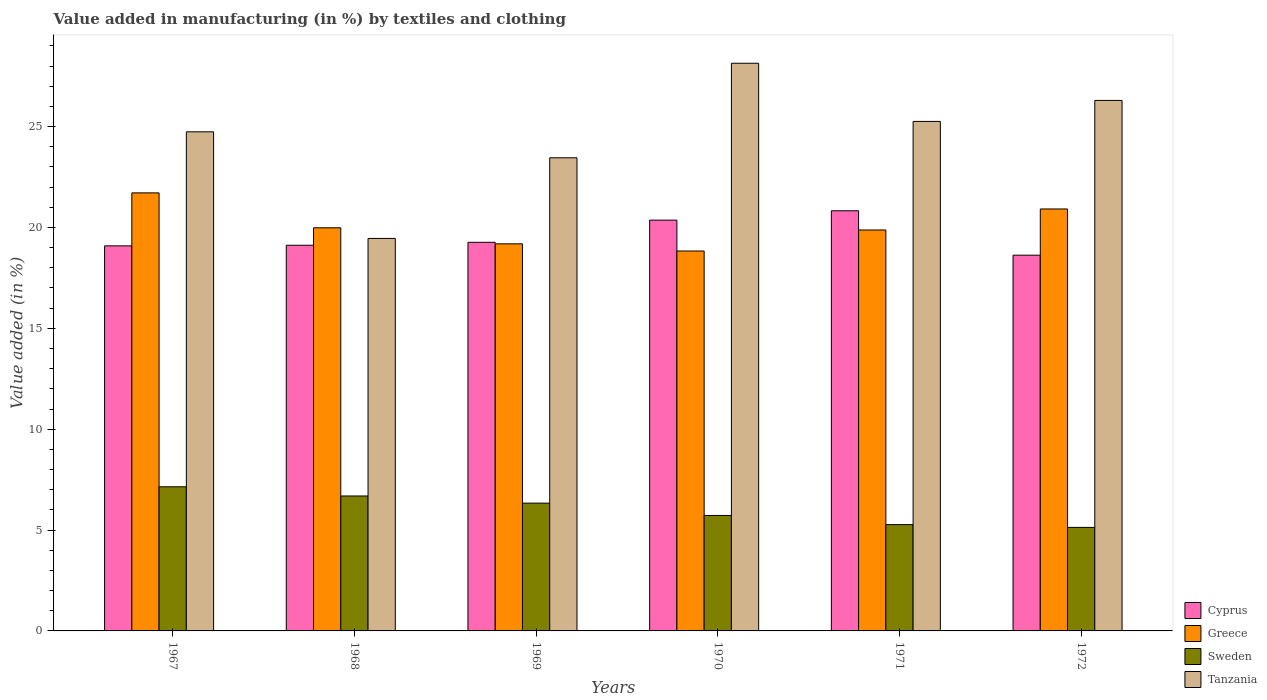How many groups of bars are there?
Provide a short and direct response. 6. Are the number of bars per tick equal to the number of legend labels?
Offer a terse response. Yes. What is the label of the 4th group of bars from the left?
Offer a very short reply. 1970. What is the percentage of value added in manufacturing by textiles and clothing in Greece in 1969?
Keep it short and to the point. 19.19. Across all years, what is the maximum percentage of value added in manufacturing by textiles and clothing in Sweden?
Give a very brief answer. 7.14. Across all years, what is the minimum percentage of value added in manufacturing by textiles and clothing in Greece?
Your response must be concise. 18.83. In which year was the percentage of value added in manufacturing by textiles and clothing in Cyprus maximum?
Ensure brevity in your answer.  1971. In which year was the percentage of value added in manufacturing by textiles and clothing in Cyprus minimum?
Provide a short and direct response. 1972. What is the total percentage of value added in manufacturing by textiles and clothing in Tanzania in the graph?
Your response must be concise. 147.35. What is the difference between the percentage of value added in manufacturing by textiles and clothing in Sweden in 1967 and that in 1971?
Give a very brief answer. 1.87. What is the difference between the percentage of value added in manufacturing by textiles and clothing in Tanzania in 1969 and the percentage of value added in manufacturing by textiles and clothing in Greece in 1970?
Make the answer very short. 4.62. What is the average percentage of value added in manufacturing by textiles and clothing in Cyprus per year?
Keep it short and to the point. 19.55. In the year 1972, what is the difference between the percentage of value added in manufacturing by textiles and clothing in Greece and percentage of value added in manufacturing by textiles and clothing in Cyprus?
Offer a terse response. 2.29. In how many years, is the percentage of value added in manufacturing by textiles and clothing in Cyprus greater than 4 %?
Make the answer very short. 6. What is the ratio of the percentage of value added in manufacturing by textiles and clothing in Tanzania in 1967 to that in 1969?
Provide a short and direct response. 1.05. What is the difference between the highest and the second highest percentage of value added in manufacturing by textiles and clothing in Greece?
Give a very brief answer. 0.8. What is the difference between the highest and the lowest percentage of value added in manufacturing by textiles and clothing in Greece?
Ensure brevity in your answer.  2.88. In how many years, is the percentage of value added in manufacturing by textiles and clothing in Greece greater than the average percentage of value added in manufacturing by textiles and clothing in Greece taken over all years?
Ensure brevity in your answer.  2. Is the sum of the percentage of value added in manufacturing by textiles and clothing in Tanzania in 1970 and 1972 greater than the maximum percentage of value added in manufacturing by textiles and clothing in Greece across all years?
Your answer should be compact. Yes. What does the 4th bar from the left in 1970 represents?
Provide a short and direct response. Tanzania. Is it the case that in every year, the sum of the percentage of value added in manufacturing by textiles and clothing in Cyprus and percentage of value added in manufacturing by textiles and clothing in Tanzania is greater than the percentage of value added in manufacturing by textiles and clothing in Greece?
Give a very brief answer. Yes. How many bars are there?
Your answer should be very brief. 24. Are all the bars in the graph horizontal?
Offer a terse response. No. How many years are there in the graph?
Provide a succinct answer. 6. How many legend labels are there?
Your answer should be very brief. 4. How are the legend labels stacked?
Your answer should be very brief. Vertical. What is the title of the graph?
Make the answer very short. Value added in manufacturing (in %) by textiles and clothing. What is the label or title of the X-axis?
Make the answer very short. Years. What is the label or title of the Y-axis?
Ensure brevity in your answer.  Value added (in %). What is the Value added (in %) of Cyprus in 1967?
Offer a terse response. 19.09. What is the Value added (in %) of Greece in 1967?
Give a very brief answer. 21.71. What is the Value added (in %) of Sweden in 1967?
Provide a short and direct response. 7.14. What is the Value added (in %) of Tanzania in 1967?
Give a very brief answer. 24.74. What is the Value added (in %) of Cyprus in 1968?
Keep it short and to the point. 19.12. What is the Value added (in %) in Greece in 1968?
Offer a very short reply. 19.98. What is the Value added (in %) in Sweden in 1968?
Offer a very short reply. 6.69. What is the Value added (in %) of Tanzania in 1968?
Provide a succinct answer. 19.46. What is the Value added (in %) of Cyprus in 1969?
Ensure brevity in your answer.  19.26. What is the Value added (in %) in Greece in 1969?
Make the answer very short. 19.19. What is the Value added (in %) of Sweden in 1969?
Provide a succinct answer. 6.33. What is the Value added (in %) in Tanzania in 1969?
Offer a very short reply. 23.45. What is the Value added (in %) of Cyprus in 1970?
Keep it short and to the point. 20.36. What is the Value added (in %) of Greece in 1970?
Provide a succinct answer. 18.83. What is the Value added (in %) in Sweden in 1970?
Provide a succinct answer. 5.72. What is the Value added (in %) of Tanzania in 1970?
Your response must be concise. 28.14. What is the Value added (in %) in Cyprus in 1971?
Your answer should be very brief. 20.83. What is the Value added (in %) of Greece in 1971?
Keep it short and to the point. 19.88. What is the Value added (in %) of Sweden in 1971?
Give a very brief answer. 5.27. What is the Value added (in %) in Tanzania in 1971?
Make the answer very short. 25.26. What is the Value added (in %) in Cyprus in 1972?
Offer a very short reply. 18.63. What is the Value added (in %) of Greece in 1972?
Offer a terse response. 20.92. What is the Value added (in %) of Sweden in 1972?
Give a very brief answer. 5.13. What is the Value added (in %) in Tanzania in 1972?
Keep it short and to the point. 26.3. Across all years, what is the maximum Value added (in %) of Cyprus?
Give a very brief answer. 20.83. Across all years, what is the maximum Value added (in %) of Greece?
Offer a terse response. 21.71. Across all years, what is the maximum Value added (in %) in Sweden?
Give a very brief answer. 7.14. Across all years, what is the maximum Value added (in %) of Tanzania?
Offer a terse response. 28.14. Across all years, what is the minimum Value added (in %) of Cyprus?
Your answer should be compact. 18.63. Across all years, what is the minimum Value added (in %) of Greece?
Keep it short and to the point. 18.83. Across all years, what is the minimum Value added (in %) in Sweden?
Make the answer very short. 5.13. Across all years, what is the minimum Value added (in %) in Tanzania?
Provide a succinct answer. 19.46. What is the total Value added (in %) in Cyprus in the graph?
Provide a succinct answer. 117.29. What is the total Value added (in %) in Greece in the graph?
Offer a terse response. 120.51. What is the total Value added (in %) of Sweden in the graph?
Offer a very short reply. 36.3. What is the total Value added (in %) of Tanzania in the graph?
Give a very brief answer. 147.35. What is the difference between the Value added (in %) of Cyprus in 1967 and that in 1968?
Give a very brief answer. -0.03. What is the difference between the Value added (in %) of Greece in 1967 and that in 1968?
Ensure brevity in your answer.  1.73. What is the difference between the Value added (in %) of Sweden in 1967 and that in 1968?
Your answer should be compact. 0.46. What is the difference between the Value added (in %) in Tanzania in 1967 and that in 1968?
Your response must be concise. 5.29. What is the difference between the Value added (in %) in Cyprus in 1967 and that in 1969?
Offer a terse response. -0.18. What is the difference between the Value added (in %) of Greece in 1967 and that in 1969?
Offer a terse response. 2.53. What is the difference between the Value added (in %) of Sweden in 1967 and that in 1969?
Offer a terse response. 0.81. What is the difference between the Value added (in %) of Tanzania in 1967 and that in 1969?
Give a very brief answer. 1.29. What is the difference between the Value added (in %) of Cyprus in 1967 and that in 1970?
Provide a succinct answer. -1.27. What is the difference between the Value added (in %) in Greece in 1967 and that in 1970?
Offer a terse response. 2.88. What is the difference between the Value added (in %) of Sweden in 1967 and that in 1970?
Ensure brevity in your answer.  1.42. What is the difference between the Value added (in %) of Tanzania in 1967 and that in 1970?
Make the answer very short. -3.4. What is the difference between the Value added (in %) of Cyprus in 1967 and that in 1971?
Keep it short and to the point. -1.74. What is the difference between the Value added (in %) of Greece in 1967 and that in 1971?
Make the answer very short. 1.84. What is the difference between the Value added (in %) of Sweden in 1967 and that in 1971?
Give a very brief answer. 1.87. What is the difference between the Value added (in %) in Tanzania in 1967 and that in 1971?
Ensure brevity in your answer.  -0.52. What is the difference between the Value added (in %) in Cyprus in 1967 and that in 1972?
Provide a short and direct response. 0.46. What is the difference between the Value added (in %) of Greece in 1967 and that in 1972?
Offer a very short reply. 0.8. What is the difference between the Value added (in %) in Sweden in 1967 and that in 1972?
Ensure brevity in your answer.  2.01. What is the difference between the Value added (in %) of Tanzania in 1967 and that in 1972?
Keep it short and to the point. -1.56. What is the difference between the Value added (in %) in Cyprus in 1968 and that in 1969?
Ensure brevity in your answer.  -0.15. What is the difference between the Value added (in %) in Greece in 1968 and that in 1969?
Give a very brief answer. 0.8. What is the difference between the Value added (in %) of Sweden in 1968 and that in 1969?
Make the answer very short. 0.35. What is the difference between the Value added (in %) in Tanzania in 1968 and that in 1969?
Make the answer very short. -4. What is the difference between the Value added (in %) of Cyprus in 1968 and that in 1970?
Offer a very short reply. -1.25. What is the difference between the Value added (in %) in Greece in 1968 and that in 1970?
Offer a very short reply. 1.15. What is the difference between the Value added (in %) in Sweden in 1968 and that in 1970?
Provide a short and direct response. 0.97. What is the difference between the Value added (in %) in Tanzania in 1968 and that in 1970?
Provide a succinct answer. -8.68. What is the difference between the Value added (in %) of Cyprus in 1968 and that in 1971?
Offer a terse response. -1.71. What is the difference between the Value added (in %) in Greece in 1968 and that in 1971?
Your answer should be very brief. 0.11. What is the difference between the Value added (in %) in Sweden in 1968 and that in 1971?
Your answer should be very brief. 1.42. What is the difference between the Value added (in %) in Tanzania in 1968 and that in 1971?
Make the answer very short. -5.8. What is the difference between the Value added (in %) in Cyprus in 1968 and that in 1972?
Your answer should be compact. 0.49. What is the difference between the Value added (in %) in Greece in 1968 and that in 1972?
Offer a very short reply. -0.93. What is the difference between the Value added (in %) of Sweden in 1968 and that in 1972?
Keep it short and to the point. 1.56. What is the difference between the Value added (in %) of Tanzania in 1968 and that in 1972?
Offer a very short reply. -6.84. What is the difference between the Value added (in %) in Cyprus in 1969 and that in 1970?
Ensure brevity in your answer.  -1.1. What is the difference between the Value added (in %) of Greece in 1969 and that in 1970?
Your answer should be very brief. 0.36. What is the difference between the Value added (in %) of Sweden in 1969 and that in 1970?
Offer a terse response. 0.61. What is the difference between the Value added (in %) of Tanzania in 1969 and that in 1970?
Your answer should be compact. -4.69. What is the difference between the Value added (in %) of Cyprus in 1969 and that in 1971?
Keep it short and to the point. -1.56. What is the difference between the Value added (in %) of Greece in 1969 and that in 1971?
Keep it short and to the point. -0.69. What is the difference between the Value added (in %) of Sweden in 1969 and that in 1971?
Offer a terse response. 1.06. What is the difference between the Value added (in %) in Tanzania in 1969 and that in 1971?
Ensure brevity in your answer.  -1.8. What is the difference between the Value added (in %) of Cyprus in 1969 and that in 1972?
Provide a succinct answer. 0.64. What is the difference between the Value added (in %) in Greece in 1969 and that in 1972?
Keep it short and to the point. -1.73. What is the difference between the Value added (in %) in Sweden in 1969 and that in 1972?
Provide a succinct answer. 1.2. What is the difference between the Value added (in %) in Tanzania in 1969 and that in 1972?
Offer a terse response. -2.84. What is the difference between the Value added (in %) in Cyprus in 1970 and that in 1971?
Provide a short and direct response. -0.46. What is the difference between the Value added (in %) in Greece in 1970 and that in 1971?
Your answer should be compact. -1.04. What is the difference between the Value added (in %) in Sweden in 1970 and that in 1971?
Provide a short and direct response. 0.45. What is the difference between the Value added (in %) of Tanzania in 1970 and that in 1971?
Give a very brief answer. 2.88. What is the difference between the Value added (in %) of Cyprus in 1970 and that in 1972?
Your answer should be compact. 1.74. What is the difference between the Value added (in %) of Greece in 1970 and that in 1972?
Offer a terse response. -2.08. What is the difference between the Value added (in %) in Sweden in 1970 and that in 1972?
Your answer should be compact. 0.59. What is the difference between the Value added (in %) in Tanzania in 1970 and that in 1972?
Offer a terse response. 1.84. What is the difference between the Value added (in %) in Cyprus in 1971 and that in 1972?
Provide a succinct answer. 2.2. What is the difference between the Value added (in %) of Greece in 1971 and that in 1972?
Keep it short and to the point. -1.04. What is the difference between the Value added (in %) of Sweden in 1971 and that in 1972?
Make the answer very short. 0.14. What is the difference between the Value added (in %) of Tanzania in 1971 and that in 1972?
Give a very brief answer. -1.04. What is the difference between the Value added (in %) in Cyprus in 1967 and the Value added (in %) in Greece in 1968?
Keep it short and to the point. -0.9. What is the difference between the Value added (in %) of Cyprus in 1967 and the Value added (in %) of Tanzania in 1968?
Make the answer very short. -0.37. What is the difference between the Value added (in %) of Greece in 1967 and the Value added (in %) of Sweden in 1968?
Ensure brevity in your answer.  15.03. What is the difference between the Value added (in %) in Greece in 1967 and the Value added (in %) in Tanzania in 1968?
Your answer should be compact. 2.26. What is the difference between the Value added (in %) of Sweden in 1967 and the Value added (in %) of Tanzania in 1968?
Your response must be concise. -12.31. What is the difference between the Value added (in %) in Cyprus in 1967 and the Value added (in %) in Greece in 1969?
Offer a very short reply. -0.1. What is the difference between the Value added (in %) in Cyprus in 1967 and the Value added (in %) in Sweden in 1969?
Your response must be concise. 12.75. What is the difference between the Value added (in %) in Cyprus in 1967 and the Value added (in %) in Tanzania in 1969?
Provide a succinct answer. -4.37. What is the difference between the Value added (in %) of Greece in 1967 and the Value added (in %) of Sweden in 1969?
Offer a terse response. 15.38. What is the difference between the Value added (in %) in Greece in 1967 and the Value added (in %) in Tanzania in 1969?
Keep it short and to the point. -1.74. What is the difference between the Value added (in %) of Sweden in 1967 and the Value added (in %) of Tanzania in 1969?
Provide a succinct answer. -16.31. What is the difference between the Value added (in %) of Cyprus in 1967 and the Value added (in %) of Greece in 1970?
Provide a succinct answer. 0.26. What is the difference between the Value added (in %) in Cyprus in 1967 and the Value added (in %) in Sweden in 1970?
Provide a succinct answer. 13.37. What is the difference between the Value added (in %) of Cyprus in 1967 and the Value added (in %) of Tanzania in 1970?
Keep it short and to the point. -9.05. What is the difference between the Value added (in %) in Greece in 1967 and the Value added (in %) in Sweden in 1970?
Make the answer very short. 15.99. What is the difference between the Value added (in %) of Greece in 1967 and the Value added (in %) of Tanzania in 1970?
Keep it short and to the point. -6.43. What is the difference between the Value added (in %) in Sweden in 1967 and the Value added (in %) in Tanzania in 1970?
Your answer should be compact. -21. What is the difference between the Value added (in %) of Cyprus in 1967 and the Value added (in %) of Greece in 1971?
Ensure brevity in your answer.  -0.79. What is the difference between the Value added (in %) of Cyprus in 1967 and the Value added (in %) of Sweden in 1971?
Offer a terse response. 13.82. What is the difference between the Value added (in %) in Cyprus in 1967 and the Value added (in %) in Tanzania in 1971?
Ensure brevity in your answer.  -6.17. What is the difference between the Value added (in %) of Greece in 1967 and the Value added (in %) of Sweden in 1971?
Your answer should be very brief. 16.44. What is the difference between the Value added (in %) of Greece in 1967 and the Value added (in %) of Tanzania in 1971?
Your answer should be very brief. -3.54. What is the difference between the Value added (in %) in Sweden in 1967 and the Value added (in %) in Tanzania in 1971?
Your answer should be very brief. -18.11. What is the difference between the Value added (in %) of Cyprus in 1967 and the Value added (in %) of Greece in 1972?
Keep it short and to the point. -1.83. What is the difference between the Value added (in %) of Cyprus in 1967 and the Value added (in %) of Sweden in 1972?
Your answer should be compact. 13.96. What is the difference between the Value added (in %) of Cyprus in 1967 and the Value added (in %) of Tanzania in 1972?
Your response must be concise. -7.21. What is the difference between the Value added (in %) in Greece in 1967 and the Value added (in %) in Sweden in 1972?
Provide a succinct answer. 16.58. What is the difference between the Value added (in %) of Greece in 1967 and the Value added (in %) of Tanzania in 1972?
Your response must be concise. -4.58. What is the difference between the Value added (in %) in Sweden in 1967 and the Value added (in %) in Tanzania in 1972?
Keep it short and to the point. -19.15. What is the difference between the Value added (in %) in Cyprus in 1968 and the Value added (in %) in Greece in 1969?
Provide a succinct answer. -0.07. What is the difference between the Value added (in %) in Cyprus in 1968 and the Value added (in %) in Sweden in 1969?
Give a very brief answer. 12.78. What is the difference between the Value added (in %) in Cyprus in 1968 and the Value added (in %) in Tanzania in 1969?
Keep it short and to the point. -4.33. What is the difference between the Value added (in %) of Greece in 1968 and the Value added (in %) of Sweden in 1969?
Give a very brief answer. 13.65. What is the difference between the Value added (in %) in Greece in 1968 and the Value added (in %) in Tanzania in 1969?
Provide a succinct answer. -3.47. What is the difference between the Value added (in %) in Sweden in 1968 and the Value added (in %) in Tanzania in 1969?
Keep it short and to the point. -16.77. What is the difference between the Value added (in %) of Cyprus in 1968 and the Value added (in %) of Greece in 1970?
Provide a succinct answer. 0.29. What is the difference between the Value added (in %) in Cyprus in 1968 and the Value added (in %) in Sweden in 1970?
Make the answer very short. 13.4. What is the difference between the Value added (in %) in Cyprus in 1968 and the Value added (in %) in Tanzania in 1970?
Your answer should be very brief. -9.02. What is the difference between the Value added (in %) of Greece in 1968 and the Value added (in %) of Sweden in 1970?
Your answer should be very brief. 14.26. What is the difference between the Value added (in %) in Greece in 1968 and the Value added (in %) in Tanzania in 1970?
Provide a succinct answer. -8.16. What is the difference between the Value added (in %) in Sweden in 1968 and the Value added (in %) in Tanzania in 1970?
Offer a terse response. -21.45. What is the difference between the Value added (in %) of Cyprus in 1968 and the Value added (in %) of Greece in 1971?
Ensure brevity in your answer.  -0.76. What is the difference between the Value added (in %) in Cyprus in 1968 and the Value added (in %) in Sweden in 1971?
Offer a very short reply. 13.85. What is the difference between the Value added (in %) of Cyprus in 1968 and the Value added (in %) of Tanzania in 1971?
Ensure brevity in your answer.  -6.14. What is the difference between the Value added (in %) in Greece in 1968 and the Value added (in %) in Sweden in 1971?
Offer a very short reply. 14.71. What is the difference between the Value added (in %) in Greece in 1968 and the Value added (in %) in Tanzania in 1971?
Offer a terse response. -5.27. What is the difference between the Value added (in %) of Sweden in 1968 and the Value added (in %) of Tanzania in 1971?
Give a very brief answer. -18.57. What is the difference between the Value added (in %) of Cyprus in 1968 and the Value added (in %) of Greece in 1972?
Keep it short and to the point. -1.8. What is the difference between the Value added (in %) in Cyprus in 1968 and the Value added (in %) in Sweden in 1972?
Your answer should be compact. 13.99. What is the difference between the Value added (in %) of Cyprus in 1968 and the Value added (in %) of Tanzania in 1972?
Your answer should be compact. -7.18. What is the difference between the Value added (in %) in Greece in 1968 and the Value added (in %) in Sweden in 1972?
Keep it short and to the point. 14.85. What is the difference between the Value added (in %) of Greece in 1968 and the Value added (in %) of Tanzania in 1972?
Offer a terse response. -6.31. What is the difference between the Value added (in %) of Sweden in 1968 and the Value added (in %) of Tanzania in 1972?
Your response must be concise. -19.61. What is the difference between the Value added (in %) in Cyprus in 1969 and the Value added (in %) in Greece in 1970?
Your response must be concise. 0.43. What is the difference between the Value added (in %) of Cyprus in 1969 and the Value added (in %) of Sweden in 1970?
Your response must be concise. 13.54. What is the difference between the Value added (in %) of Cyprus in 1969 and the Value added (in %) of Tanzania in 1970?
Offer a terse response. -8.88. What is the difference between the Value added (in %) in Greece in 1969 and the Value added (in %) in Sweden in 1970?
Keep it short and to the point. 13.47. What is the difference between the Value added (in %) in Greece in 1969 and the Value added (in %) in Tanzania in 1970?
Your answer should be compact. -8.95. What is the difference between the Value added (in %) of Sweden in 1969 and the Value added (in %) of Tanzania in 1970?
Offer a very short reply. -21.81. What is the difference between the Value added (in %) of Cyprus in 1969 and the Value added (in %) of Greece in 1971?
Ensure brevity in your answer.  -0.61. What is the difference between the Value added (in %) in Cyprus in 1969 and the Value added (in %) in Sweden in 1971?
Offer a terse response. 13.99. What is the difference between the Value added (in %) of Cyprus in 1969 and the Value added (in %) of Tanzania in 1971?
Keep it short and to the point. -5.99. What is the difference between the Value added (in %) in Greece in 1969 and the Value added (in %) in Sweden in 1971?
Provide a short and direct response. 13.92. What is the difference between the Value added (in %) of Greece in 1969 and the Value added (in %) of Tanzania in 1971?
Your response must be concise. -6.07. What is the difference between the Value added (in %) of Sweden in 1969 and the Value added (in %) of Tanzania in 1971?
Keep it short and to the point. -18.92. What is the difference between the Value added (in %) of Cyprus in 1969 and the Value added (in %) of Greece in 1972?
Keep it short and to the point. -1.65. What is the difference between the Value added (in %) of Cyprus in 1969 and the Value added (in %) of Sweden in 1972?
Give a very brief answer. 14.13. What is the difference between the Value added (in %) of Cyprus in 1969 and the Value added (in %) of Tanzania in 1972?
Give a very brief answer. -7.03. What is the difference between the Value added (in %) of Greece in 1969 and the Value added (in %) of Sweden in 1972?
Keep it short and to the point. 14.06. What is the difference between the Value added (in %) in Greece in 1969 and the Value added (in %) in Tanzania in 1972?
Offer a very short reply. -7.11. What is the difference between the Value added (in %) of Sweden in 1969 and the Value added (in %) of Tanzania in 1972?
Give a very brief answer. -19.96. What is the difference between the Value added (in %) in Cyprus in 1970 and the Value added (in %) in Greece in 1971?
Ensure brevity in your answer.  0.49. What is the difference between the Value added (in %) of Cyprus in 1970 and the Value added (in %) of Sweden in 1971?
Offer a very short reply. 15.09. What is the difference between the Value added (in %) of Cyprus in 1970 and the Value added (in %) of Tanzania in 1971?
Ensure brevity in your answer.  -4.89. What is the difference between the Value added (in %) in Greece in 1970 and the Value added (in %) in Sweden in 1971?
Keep it short and to the point. 13.56. What is the difference between the Value added (in %) of Greece in 1970 and the Value added (in %) of Tanzania in 1971?
Offer a terse response. -6.42. What is the difference between the Value added (in %) of Sweden in 1970 and the Value added (in %) of Tanzania in 1971?
Provide a short and direct response. -19.53. What is the difference between the Value added (in %) of Cyprus in 1970 and the Value added (in %) of Greece in 1972?
Your answer should be compact. -0.55. What is the difference between the Value added (in %) of Cyprus in 1970 and the Value added (in %) of Sweden in 1972?
Give a very brief answer. 15.23. What is the difference between the Value added (in %) of Cyprus in 1970 and the Value added (in %) of Tanzania in 1972?
Your response must be concise. -5.93. What is the difference between the Value added (in %) in Greece in 1970 and the Value added (in %) in Sweden in 1972?
Offer a very short reply. 13.7. What is the difference between the Value added (in %) in Greece in 1970 and the Value added (in %) in Tanzania in 1972?
Offer a very short reply. -7.47. What is the difference between the Value added (in %) of Sweden in 1970 and the Value added (in %) of Tanzania in 1972?
Keep it short and to the point. -20.57. What is the difference between the Value added (in %) of Cyprus in 1971 and the Value added (in %) of Greece in 1972?
Your response must be concise. -0.09. What is the difference between the Value added (in %) in Cyprus in 1971 and the Value added (in %) in Sweden in 1972?
Make the answer very short. 15.7. What is the difference between the Value added (in %) of Cyprus in 1971 and the Value added (in %) of Tanzania in 1972?
Offer a very short reply. -5.47. What is the difference between the Value added (in %) of Greece in 1971 and the Value added (in %) of Sweden in 1972?
Ensure brevity in your answer.  14.74. What is the difference between the Value added (in %) in Greece in 1971 and the Value added (in %) in Tanzania in 1972?
Provide a short and direct response. -6.42. What is the difference between the Value added (in %) of Sweden in 1971 and the Value added (in %) of Tanzania in 1972?
Your answer should be compact. -21.03. What is the average Value added (in %) of Cyprus per year?
Ensure brevity in your answer.  19.55. What is the average Value added (in %) in Greece per year?
Offer a very short reply. 20.09. What is the average Value added (in %) of Sweden per year?
Ensure brevity in your answer.  6.05. What is the average Value added (in %) in Tanzania per year?
Provide a short and direct response. 24.56. In the year 1967, what is the difference between the Value added (in %) of Cyprus and Value added (in %) of Greece?
Provide a short and direct response. -2.63. In the year 1967, what is the difference between the Value added (in %) of Cyprus and Value added (in %) of Sweden?
Your answer should be very brief. 11.94. In the year 1967, what is the difference between the Value added (in %) in Cyprus and Value added (in %) in Tanzania?
Give a very brief answer. -5.65. In the year 1967, what is the difference between the Value added (in %) in Greece and Value added (in %) in Sweden?
Offer a very short reply. 14.57. In the year 1967, what is the difference between the Value added (in %) of Greece and Value added (in %) of Tanzania?
Offer a terse response. -3.03. In the year 1967, what is the difference between the Value added (in %) in Sweden and Value added (in %) in Tanzania?
Make the answer very short. -17.6. In the year 1968, what is the difference between the Value added (in %) in Cyprus and Value added (in %) in Greece?
Provide a short and direct response. -0.87. In the year 1968, what is the difference between the Value added (in %) of Cyprus and Value added (in %) of Sweden?
Your answer should be very brief. 12.43. In the year 1968, what is the difference between the Value added (in %) in Cyprus and Value added (in %) in Tanzania?
Give a very brief answer. -0.34. In the year 1968, what is the difference between the Value added (in %) of Greece and Value added (in %) of Sweden?
Your response must be concise. 13.3. In the year 1968, what is the difference between the Value added (in %) of Greece and Value added (in %) of Tanzania?
Provide a succinct answer. 0.53. In the year 1968, what is the difference between the Value added (in %) in Sweden and Value added (in %) in Tanzania?
Your answer should be very brief. -12.77. In the year 1969, what is the difference between the Value added (in %) in Cyprus and Value added (in %) in Greece?
Keep it short and to the point. 0.08. In the year 1969, what is the difference between the Value added (in %) in Cyprus and Value added (in %) in Sweden?
Keep it short and to the point. 12.93. In the year 1969, what is the difference between the Value added (in %) in Cyprus and Value added (in %) in Tanzania?
Offer a terse response. -4.19. In the year 1969, what is the difference between the Value added (in %) in Greece and Value added (in %) in Sweden?
Provide a succinct answer. 12.85. In the year 1969, what is the difference between the Value added (in %) of Greece and Value added (in %) of Tanzania?
Give a very brief answer. -4.27. In the year 1969, what is the difference between the Value added (in %) of Sweden and Value added (in %) of Tanzania?
Offer a terse response. -17.12. In the year 1970, what is the difference between the Value added (in %) of Cyprus and Value added (in %) of Greece?
Your response must be concise. 1.53. In the year 1970, what is the difference between the Value added (in %) in Cyprus and Value added (in %) in Sweden?
Your answer should be compact. 14.64. In the year 1970, what is the difference between the Value added (in %) in Cyprus and Value added (in %) in Tanzania?
Provide a short and direct response. -7.78. In the year 1970, what is the difference between the Value added (in %) in Greece and Value added (in %) in Sweden?
Provide a short and direct response. 13.11. In the year 1970, what is the difference between the Value added (in %) of Greece and Value added (in %) of Tanzania?
Offer a very short reply. -9.31. In the year 1970, what is the difference between the Value added (in %) in Sweden and Value added (in %) in Tanzania?
Provide a succinct answer. -22.42. In the year 1971, what is the difference between the Value added (in %) of Cyprus and Value added (in %) of Greece?
Your answer should be very brief. 0.95. In the year 1971, what is the difference between the Value added (in %) of Cyprus and Value added (in %) of Sweden?
Make the answer very short. 15.56. In the year 1971, what is the difference between the Value added (in %) in Cyprus and Value added (in %) in Tanzania?
Provide a short and direct response. -4.43. In the year 1971, what is the difference between the Value added (in %) of Greece and Value added (in %) of Sweden?
Keep it short and to the point. 14.61. In the year 1971, what is the difference between the Value added (in %) of Greece and Value added (in %) of Tanzania?
Your response must be concise. -5.38. In the year 1971, what is the difference between the Value added (in %) in Sweden and Value added (in %) in Tanzania?
Give a very brief answer. -19.99. In the year 1972, what is the difference between the Value added (in %) in Cyprus and Value added (in %) in Greece?
Your answer should be compact. -2.29. In the year 1972, what is the difference between the Value added (in %) of Cyprus and Value added (in %) of Sweden?
Give a very brief answer. 13.49. In the year 1972, what is the difference between the Value added (in %) of Cyprus and Value added (in %) of Tanzania?
Keep it short and to the point. -7.67. In the year 1972, what is the difference between the Value added (in %) of Greece and Value added (in %) of Sweden?
Your response must be concise. 15.79. In the year 1972, what is the difference between the Value added (in %) in Greece and Value added (in %) in Tanzania?
Give a very brief answer. -5.38. In the year 1972, what is the difference between the Value added (in %) of Sweden and Value added (in %) of Tanzania?
Provide a short and direct response. -21.17. What is the ratio of the Value added (in %) of Greece in 1967 to that in 1968?
Your response must be concise. 1.09. What is the ratio of the Value added (in %) in Sweden in 1967 to that in 1968?
Provide a succinct answer. 1.07. What is the ratio of the Value added (in %) of Tanzania in 1967 to that in 1968?
Offer a terse response. 1.27. What is the ratio of the Value added (in %) in Cyprus in 1967 to that in 1969?
Give a very brief answer. 0.99. What is the ratio of the Value added (in %) of Greece in 1967 to that in 1969?
Keep it short and to the point. 1.13. What is the ratio of the Value added (in %) in Sweden in 1967 to that in 1969?
Give a very brief answer. 1.13. What is the ratio of the Value added (in %) in Tanzania in 1967 to that in 1969?
Give a very brief answer. 1.05. What is the ratio of the Value added (in %) in Cyprus in 1967 to that in 1970?
Make the answer very short. 0.94. What is the ratio of the Value added (in %) of Greece in 1967 to that in 1970?
Make the answer very short. 1.15. What is the ratio of the Value added (in %) in Sweden in 1967 to that in 1970?
Offer a very short reply. 1.25. What is the ratio of the Value added (in %) of Tanzania in 1967 to that in 1970?
Offer a terse response. 0.88. What is the ratio of the Value added (in %) of Cyprus in 1967 to that in 1971?
Your response must be concise. 0.92. What is the ratio of the Value added (in %) in Greece in 1967 to that in 1971?
Ensure brevity in your answer.  1.09. What is the ratio of the Value added (in %) of Sweden in 1967 to that in 1971?
Provide a succinct answer. 1.36. What is the ratio of the Value added (in %) of Tanzania in 1967 to that in 1971?
Your response must be concise. 0.98. What is the ratio of the Value added (in %) of Cyprus in 1967 to that in 1972?
Offer a terse response. 1.02. What is the ratio of the Value added (in %) in Greece in 1967 to that in 1972?
Your answer should be very brief. 1.04. What is the ratio of the Value added (in %) of Sweden in 1967 to that in 1972?
Keep it short and to the point. 1.39. What is the ratio of the Value added (in %) of Tanzania in 1967 to that in 1972?
Offer a terse response. 0.94. What is the ratio of the Value added (in %) in Cyprus in 1968 to that in 1969?
Provide a succinct answer. 0.99. What is the ratio of the Value added (in %) of Greece in 1968 to that in 1969?
Provide a short and direct response. 1.04. What is the ratio of the Value added (in %) in Sweden in 1968 to that in 1969?
Provide a succinct answer. 1.06. What is the ratio of the Value added (in %) of Tanzania in 1968 to that in 1969?
Your answer should be very brief. 0.83. What is the ratio of the Value added (in %) of Cyprus in 1968 to that in 1970?
Ensure brevity in your answer.  0.94. What is the ratio of the Value added (in %) of Greece in 1968 to that in 1970?
Make the answer very short. 1.06. What is the ratio of the Value added (in %) in Sweden in 1968 to that in 1970?
Offer a terse response. 1.17. What is the ratio of the Value added (in %) in Tanzania in 1968 to that in 1970?
Provide a short and direct response. 0.69. What is the ratio of the Value added (in %) in Cyprus in 1968 to that in 1971?
Provide a succinct answer. 0.92. What is the ratio of the Value added (in %) in Sweden in 1968 to that in 1971?
Keep it short and to the point. 1.27. What is the ratio of the Value added (in %) in Tanzania in 1968 to that in 1971?
Provide a succinct answer. 0.77. What is the ratio of the Value added (in %) in Cyprus in 1968 to that in 1972?
Provide a succinct answer. 1.03. What is the ratio of the Value added (in %) in Greece in 1968 to that in 1972?
Ensure brevity in your answer.  0.96. What is the ratio of the Value added (in %) in Sweden in 1968 to that in 1972?
Provide a short and direct response. 1.3. What is the ratio of the Value added (in %) in Tanzania in 1968 to that in 1972?
Your response must be concise. 0.74. What is the ratio of the Value added (in %) in Cyprus in 1969 to that in 1970?
Your answer should be very brief. 0.95. What is the ratio of the Value added (in %) in Greece in 1969 to that in 1970?
Offer a terse response. 1.02. What is the ratio of the Value added (in %) of Sweden in 1969 to that in 1970?
Offer a very short reply. 1.11. What is the ratio of the Value added (in %) in Tanzania in 1969 to that in 1970?
Your answer should be compact. 0.83. What is the ratio of the Value added (in %) of Cyprus in 1969 to that in 1971?
Offer a very short reply. 0.92. What is the ratio of the Value added (in %) in Greece in 1969 to that in 1971?
Offer a terse response. 0.97. What is the ratio of the Value added (in %) of Sweden in 1969 to that in 1971?
Make the answer very short. 1.2. What is the ratio of the Value added (in %) in Cyprus in 1969 to that in 1972?
Offer a very short reply. 1.03. What is the ratio of the Value added (in %) in Greece in 1969 to that in 1972?
Give a very brief answer. 0.92. What is the ratio of the Value added (in %) of Sweden in 1969 to that in 1972?
Provide a succinct answer. 1.23. What is the ratio of the Value added (in %) in Tanzania in 1969 to that in 1972?
Your answer should be compact. 0.89. What is the ratio of the Value added (in %) in Cyprus in 1970 to that in 1971?
Your answer should be compact. 0.98. What is the ratio of the Value added (in %) of Greece in 1970 to that in 1971?
Keep it short and to the point. 0.95. What is the ratio of the Value added (in %) of Sweden in 1970 to that in 1971?
Your response must be concise. 1.09. What is the ratio of the Value added (in %) of Tanzania in 1970 to that in 1971?
Offer a terse response. 1.11. What is the ratio of the Value added (in %) in Cyprus in 1970 to that in 1972?
Ensure brevity in your answer.  1.09. What is the ratio of the Value added (in %) of Greece in 1970 to that in 1972?
Provide a succinct answer. 0.9. What is the ratio of the Value added (in %) in Sweden in 1970 to that in 1972?
Your answer should be compact. 1.12. What is the ratio of the Value added (in %) in Tanzania in 1970 to that in 1972?
Keep it short and to the point. 1.07. What is the ratio of the Value added (in %) of Cyprus in 1971 to that in 1972?
Give a very brief answer. 1.12. What is the ratio of the Value added (in %) of Greece in 1971 to that in 1972?
Your response must be concise. 0.95. What is the ratio of the Value added (in %) in Sweden in 1971 to that in 1972?
Offer a very short reply. 1.03. What is the ratio of the Value added (in %) of Tanzania in 1971 to that in 1972?
Your answer should be compact. 0.96. What is the difference between the highest and the second highest Value added (in %) of Cyprus?
Provide a short and direct response. 0.46. What is the difference between the highest and the second highest Value added (in %) in Greece?
Make the answer very short. 0.8. What is the difference between the highest and the second highest Value added (in %) of Sweden?
Provide a short and direct response. 0.46. What is the difference between the highest and the second highest Value added (in %) in Tanzania?
Provide a short and direct response. 1.84. What is the difference between the highest and the lowest Value added (in %) of Cyprus?
Your answer should be compact. 2.2. What is the difference between the highest and the lowest Value added (in %) in Greece?
Provide a succinct answer. 2.88. What is the difference between the highest and the lowest Value added (in %) of Sweden?
Your response must be concise. 2.01. What is the difference between the highest and the lowest Value added (in %) of Tanzania?
Keep it short and to the point. 8.68. 